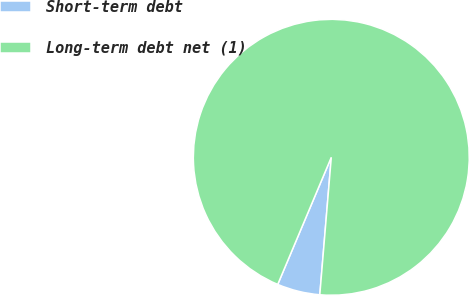<chart> <loc_0><loc_0><loc_500><loc_500><pie_chart><fcel>Short-term debt<fcel>Long-term debt net (1)<nl><fcel>5.02%<fcel>94.98%<nl></chart> 